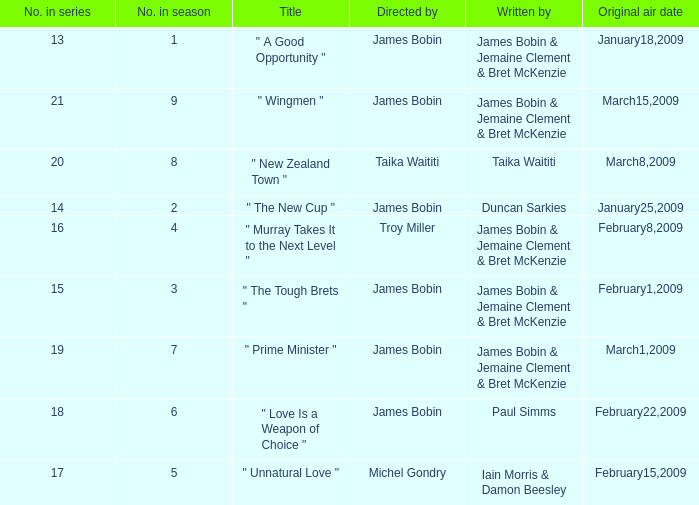 what's the title where original air date is january18,2009 " A Good Opportunity ". 